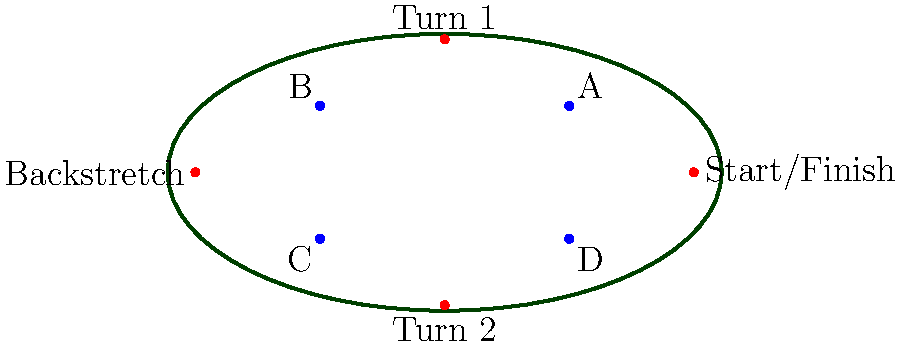As a track owner, you need to place cameras to capture key moments of the race. Given the oval track layout shown, with red dots indicating critical points (Start/Finish, Turn 1, Backstretch, and Turn 2), which two camera positions (labeled A, B, C, and D in blue) would provide the best coverage of all four critical points? To determine the best camera positions, we need to consider the following steps:

1. Analyze the track layout:
   - The track is an oval shape with four critical points marked in red.
   - There are four potential camera positions marked A, B, C, and D in blue.

2. Evaluate each camera position:
   - Camera A: Can see Start/Finish and Turn 1 clearly, partial view of Turn 2.
   - Camera B: Can see Turn 1 and Backstretch clearly, partial view of Start/Finish.
   - Camera C: Can see Backstretch and Turn 2 clearly, partial view of Turn 1.
   - Camera D: Can see Turn 2 and Start/Finish clearly, partial view of Backstretch.

3. Determine the best combination:
   - To cover all four critical points, we need two cameras on opposite sides of the track.
   - The combination of B and D provides the best coverage:
     * Camera B covers Turn 1 and Backstretch fully, plus partial view of Start/Finish.
     * Camera D covers Turn 2 and Start/Finish fully, plus partial view of Backstretch.
   - Together, B and D ensure that all four critical points are captured with at least one camera having a clear view of each point.

4. Consider alternatives:
   - A and C would also cover all points, but with less optimal angles for some key areas.
   - Other combinations (A-B, B-C, C-D, D-A) would leave some critical points with poor coverage.

Therefore, the best two camera positions for capturing all four critical race moments are B and D.
Answer: B and D 